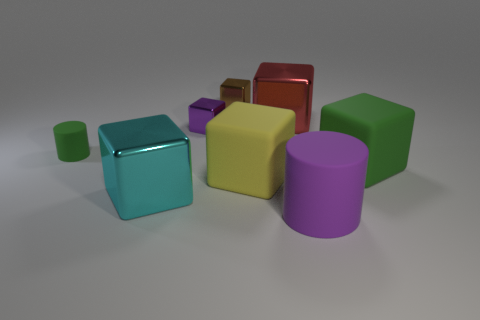There is a matte cylinder that is behind the large matte cube behind the big yellow block; what size is it?
Provide a succinct answer. Small. What is the big block that is in front of the large green cube and to the right of the purple metal block made of?
Keep it short and to the point. Rubber. How many other objects are the same size as the brown block?
Ensure brevity in your answer.  2. The tiny cylinder is what color?
Offer a terse response. Green. Do the matte cylinder right of the big cyan shiny thing and the large shiny thing in front of the green matte cube have the same color?
Give a very brief answer. No. What size is the yellow thing?
Your response must be concise. Large. How big is the purple thing that is in front of the big cyan metal cube?
Give a very brief answer. Large. The rubber thing that is both behind the yellow matte object and to the left of the purple matte cylinder has what shape?
Give a very brief answer. Cylinder. How many other things are the same shape as the cyan object?
Provide a succinct answer. 5. There is a cylinder that is the same size as the purple metal object; what color is it?
Offer a very short reply. Green. 